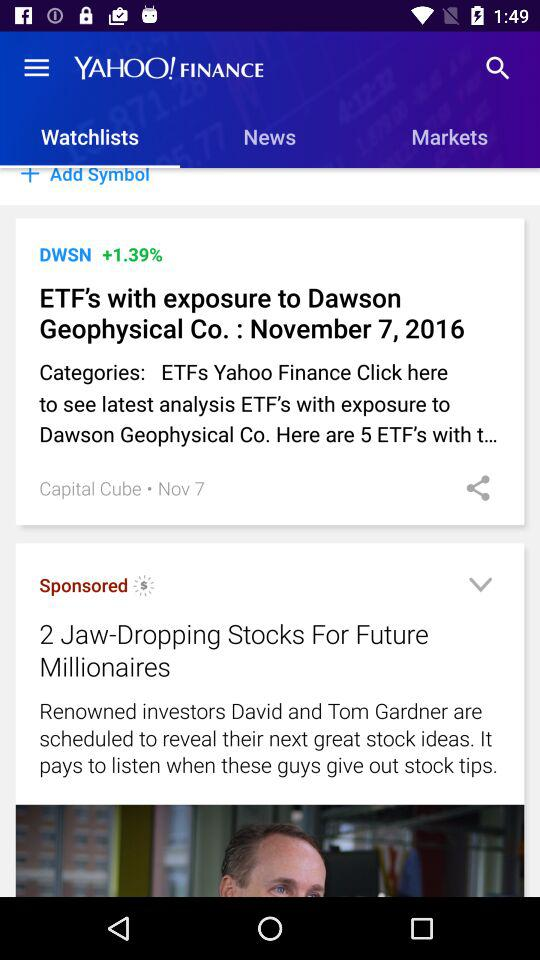What is the percentage change in DWSN? The percentage change in DWSN is +1.39. 